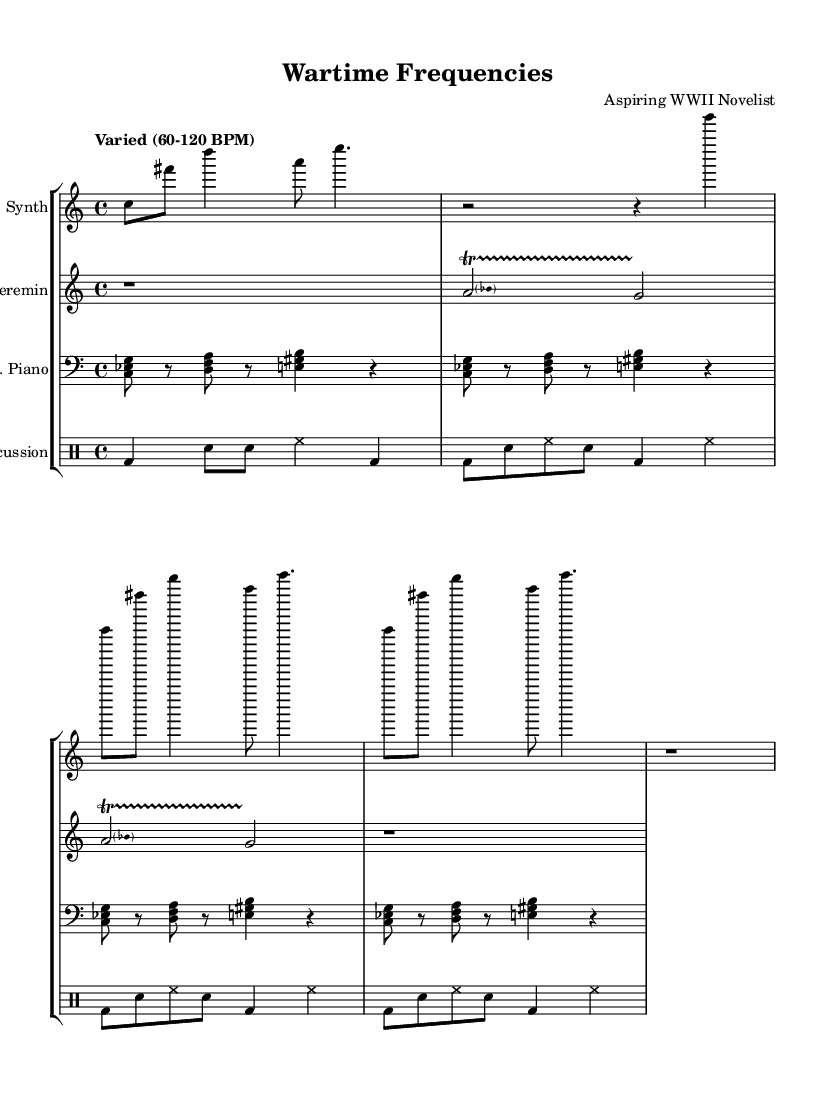What is the time signature of this music? The time signature is indicated at the beginning of the score as 4/4, which means there are four beats per measure.
Answer: 4/4 What is the tempo marking for the piece? The tempo marking is stated in the global context as "Varied (60-120 BPM)", indicating a range of beats per minute for performance.
Answer: Varied (60-120 BPM) How many staves are in the score? The score contains four staves: one for the synthesizer, one for the theremin, one for the prepared piano, and one for percussion.
Answer: Four What type of instrument is used for the first staff? The first staff is labeled "Synth", indicating that it is for a synthesizer.
Answer: Synth Identify one technique used in the theremin part. The theremin features a pitched trill, which is a rapid alternation between two notes, as described in the repeated section of the score.
Answer: Pitched trill How many measures are there in the prepared piano part? The prepared piano part has a repeating section of four measures which continues for a total of four iterations, resulting in a total of sixteen measures.
Answer: Sixteen What kind of percussion instruments are indicated in the drum staff? The percussion staff contains indications for bass drum (bd), snare drum (sn), and hi-hat (hh), which are common percussion instruments.
Answer: Bass drum, snare drum, hi-hat 